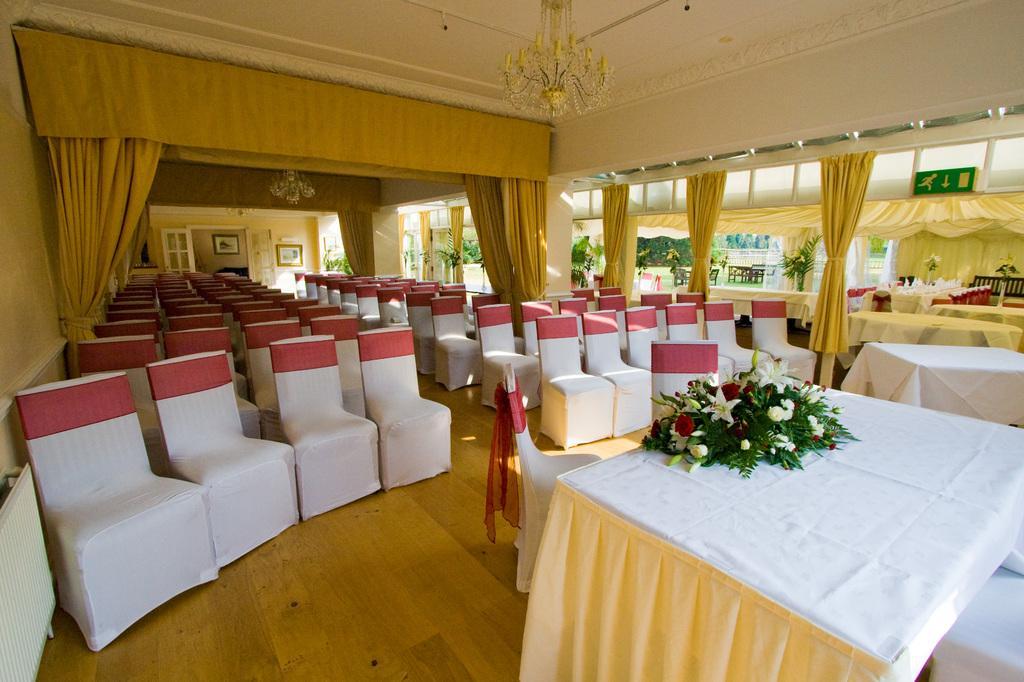Please provide a concise description of this image. On the right side of the picture we can see trees, plants. At the top we can see a sign board and chandeliers. Here we can see curtains. Far we can see frames on a wall. We can see chairs and tables. This is a flower bouquet on a table. This is a floor. 